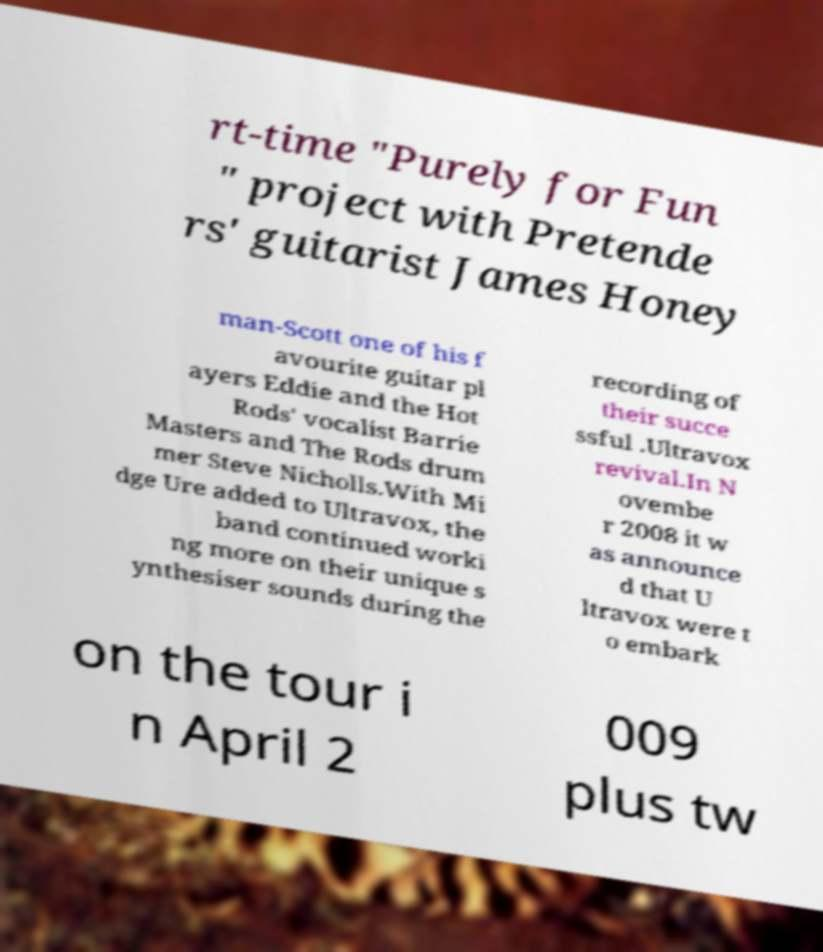I need the written content from this picture converted into text. Can you do that? rt-time "Purely for Fun " project with Pretende rs' guitarist James Honey man-Scott one of his f avourite guitar pl ayers Eddie and the Hot Rods' vocalist Barrie Masters and The Rods drum mer Steve Nicholls.With Mi dge Ure added to Ultravox, the band continued worki ng more on their unique s ynthesiser sounds during the recording of their succe ssful .Ultravox revival.In N ovembe r 2008 it w as announce d that U ltravox were t o embark on the tour i n April 2 009 plus tw 